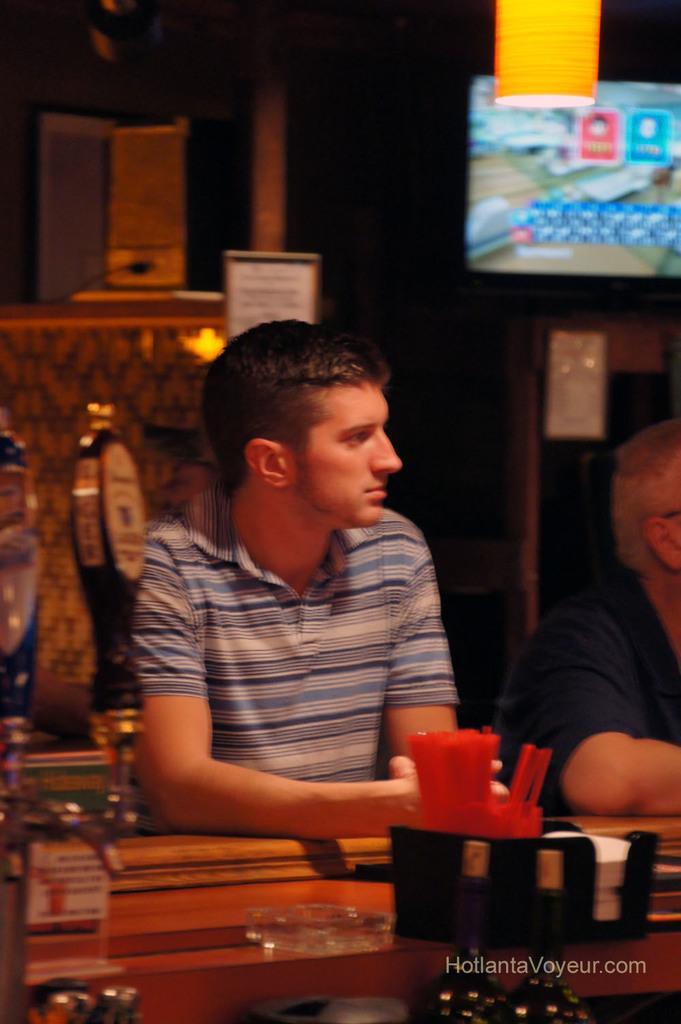How would you summarize this image in a sentence or two? The person is sitting in front of a table which has some objects on it and there is other person sitting beside him. 